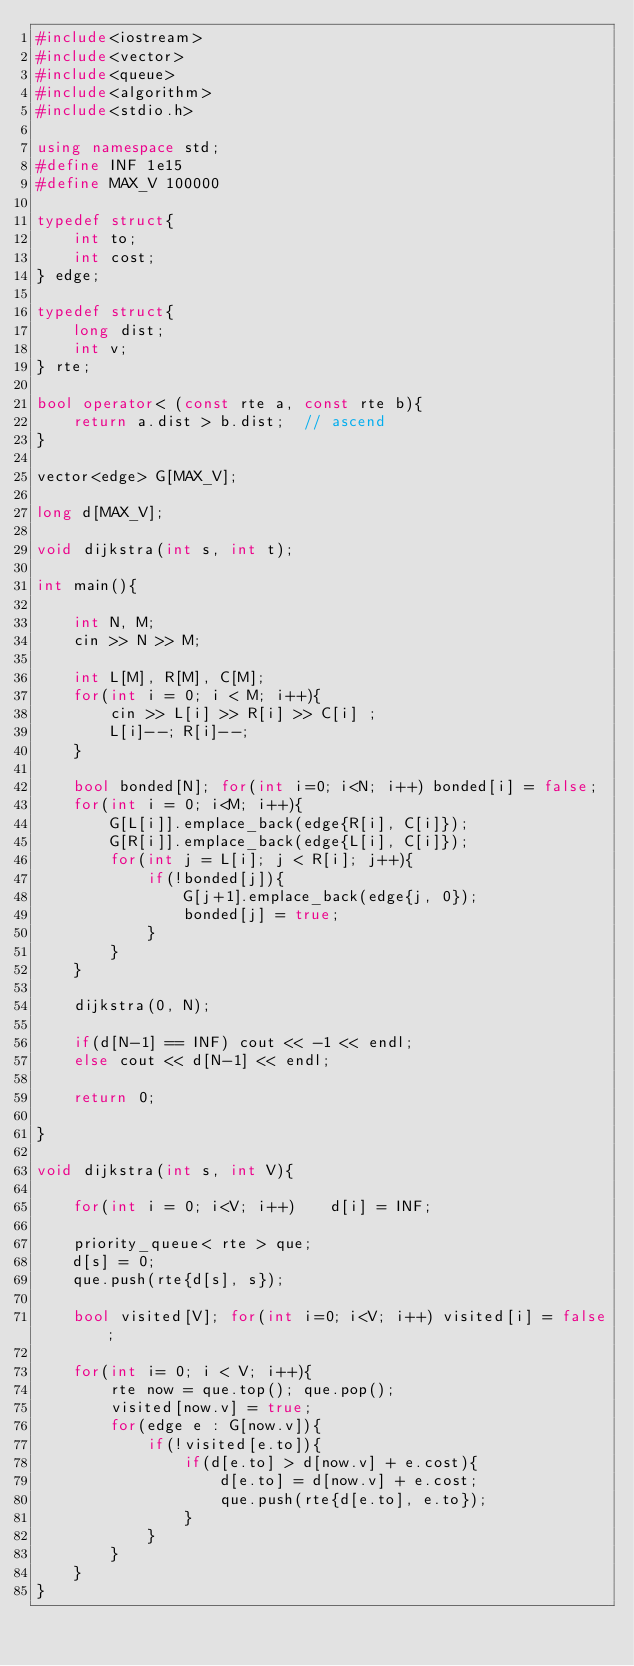<code> <loc_0><loc_0><loc_500><loc_500><_C++_>#include<iostream>
#include<vector>
#include<queue>
#include<algorithm>
#include<stdio.h>

using namespace std;
#define INF 1e15
#define MAX_V 100000

typedef struct{
    int to;
    int cost;
} edge;

typedef struct{
    long dist;
    int v;
} rte;

bool operator< (const rte a, const rte b){
    return a.dist > b.dist;  // ascend
}

vector<edge> G[MAX_V];

long d[MAX_V];

void dijkstra(int s, int t);

int main(){

    int N, M;
    cin >> N >> M;

    int L[M], R[M], C[M];
    for(int i = 0; i < M; i++){
        cin >> L[i] >> R[i] >> C[i] ;
        L[i]--; R[i]--; 
    }

    bool bonded[N]; for(int i=0; i<N; i++) bonded[i] = false;
    for(int i = 0; i<M; i++){
        G[L[i]].emplace_back(edge{R[i], C[i]});
        G[R[i]].emplace_back(edge{L[i], C[i]});
        for(int j = L[i]; j < R[i]; j++){
            if(!bonded[j]){
                G[j+1].emplace_back(edge{j, 0});
                bonded[j] = true;
            }
        }
    }

    dijkstra(0, N);

    if(d[N-1] == INF) cout << -1 << endl;
    else cout << d[N-1] << endl;

    return 0;
    
}

void dijkstra(int s, int V){

    for(int i = 0; i<V; i++)    d[i] = INF;

    priority_queue< rte > que;
    d[s] = 0;
    que.push(rte{d[s], s});

    bool visited[V]; for(int i=0; i<V; i++) visited[i] = false;
    
    for(int i= 0; i < V; i++){
        rte now = que.top(); que.pop();
        visited[now.v] = true;
        for(edge e : G[now.v]){
            if(!visited[e.to]){
                if(d[e.to] > d[now.v] + e.cost){
                    d[e.to] = d[now.v] + e.cost;
                    que.push(rte{d[e.to], e.to});
                }
            }
        }
    }
}</code> 